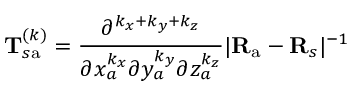<formula> <loc_0><loc_0><loc_500><loc_500>T _ { s a } ^ { ( k ) } = \frac { \partial ^ { k _ { x } + k _ { y } + k _ { z } } } { \partial x _ { a } ^ { k _ { x } } \partial y _ { a } ^ { k _ { y } } \partial z _ { a } ^ { k _ { z } } } | R _ { a } - R _ { s } | ^ { - 1 }</formula> 